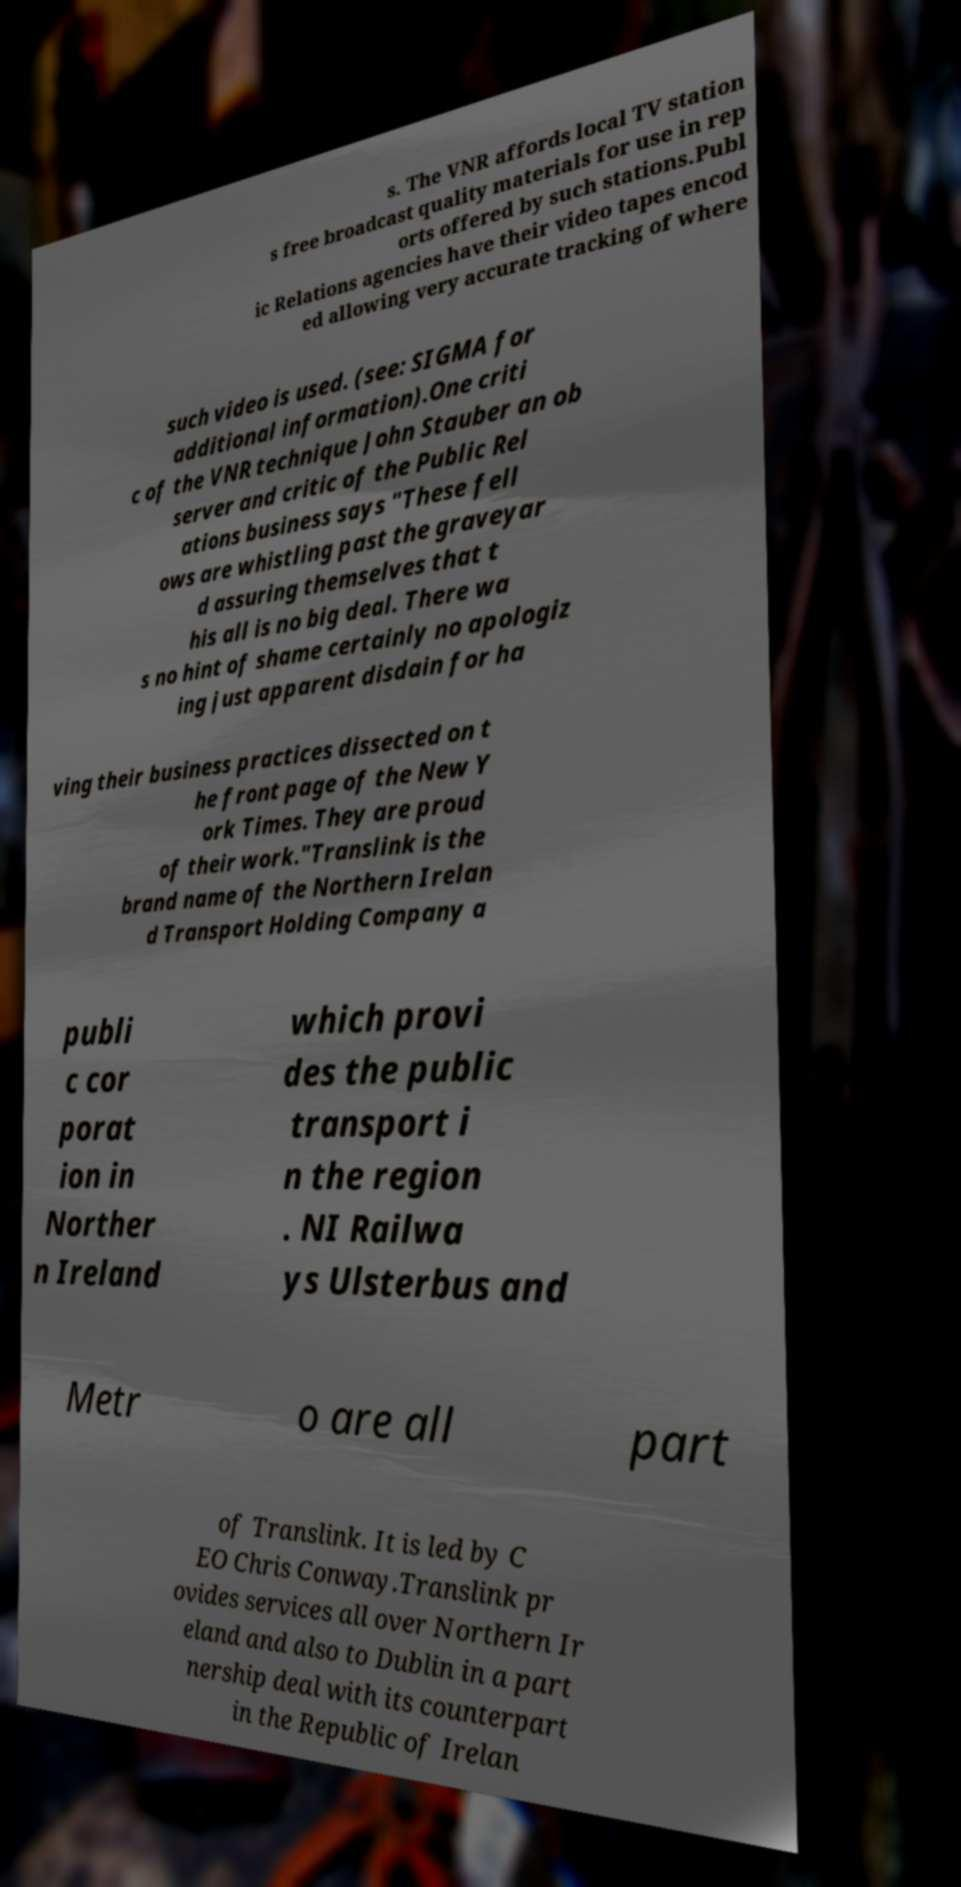Please read and relay the text visible in this image. What does it say? s. The VNR affords local TV station s free broadcast quality materials for use in rep orts offered by such stations.Publ ic Relations agencies have their video tapes encod ed allowing very accurate tracking of where such video is used. (see: SIGMA for additional information).One criti c of the VNR technique John Stauber an ob server and critic of the Public Rel ations business says "These fell ows are whistling past the graveyar d assuring themselves that t his all is no big deal. There wa s no hint of shame certainly no apologiz ing just apparent disdain for ha ving their business practices dissected on t he front page of the New Y ork Times. They are proud of their work."Translink is the brand name of the Northern Irelan d Transport Holding Company a publi c cor porat ion in Norther n Ireland which provi des the public transport i n the region . NI Railwa ys Ulsterbus and Metr o are all part of Translink. It is led by C EO Chris Conway.Translink pr ovides services all over Northern Ir eland and also to Dublin in a part nership deal with its counterpart in the Republic of Irelan 